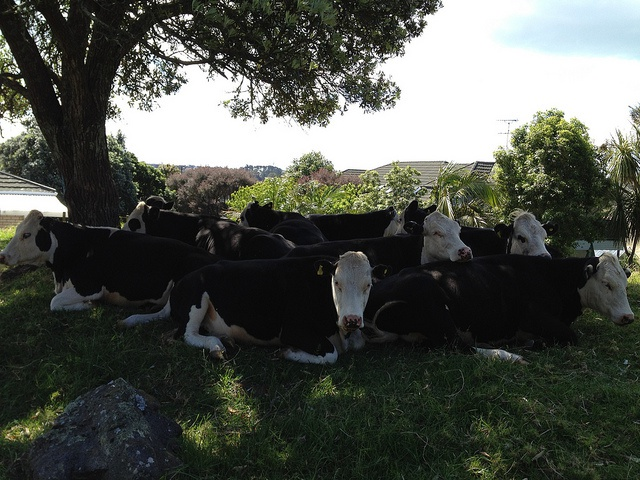Describe the objects in this image and their specific colors. I can see cow in black, gray, and purple tones, cow in black, gray, and darkblue tones, cow in black and gray tones, cow in black and gray tones, and cow in black, gray, darkgreen, and darkgray tones in this image. 